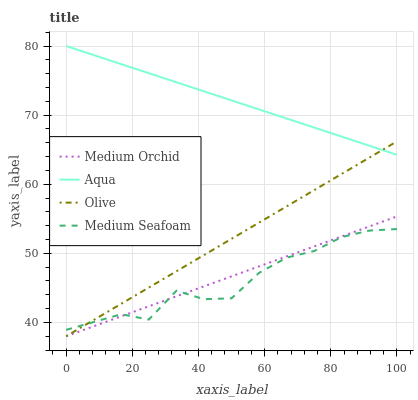Does Medium Seafoam have the minimum area under the curve?
Answer yes or no. Yes. Does Aqua have the maximum area under the curve?
Answer yes or no. Yes. Does Medium Orchid have the minimum area under the curve?
Answer yes or no. No. Does Medium Orchid have the maximum area under the curve?
Answer yes or no. No. Is Aqua the smoothest?
Answer yes or no. Yes. Is Medium Seafoam the roughest?
Answer yes or no. Yes. Is Medium Orchid the smoothest?
Answer yes or no. No. Is Medium Orchid the roughest?
Answer yes or no. No. Does Aqua have the lowest value?
Answer yes or no. No. Does Medium Orchid have the highest value?
Answer yes or no. No. Is Medium Seafoam less than Aqua?
Answer yes or no. Yes. Is Aqua greater than Medium Seafoam?
Answer yes or no. Yes. Does Medium Seafoam intersect Aqua?
Answer yes or no. No. 